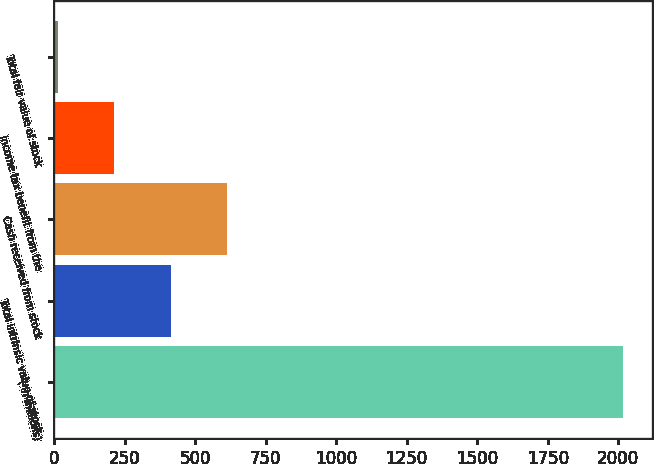Convert chart to OTSL. <chart><loc_0><loc_0><loc_500><loc_500><bar_chart><fcel>( in millions)<fcel>Total intrinsic value of stock<fcel>Cash received from stock<fcel>Income tax benefit from the<fcel>Total fair value of stock<nl><fcel>2017<fcel>413.8<fcel>614.2<fcel>213.4<fcel>13<nl></chart> 